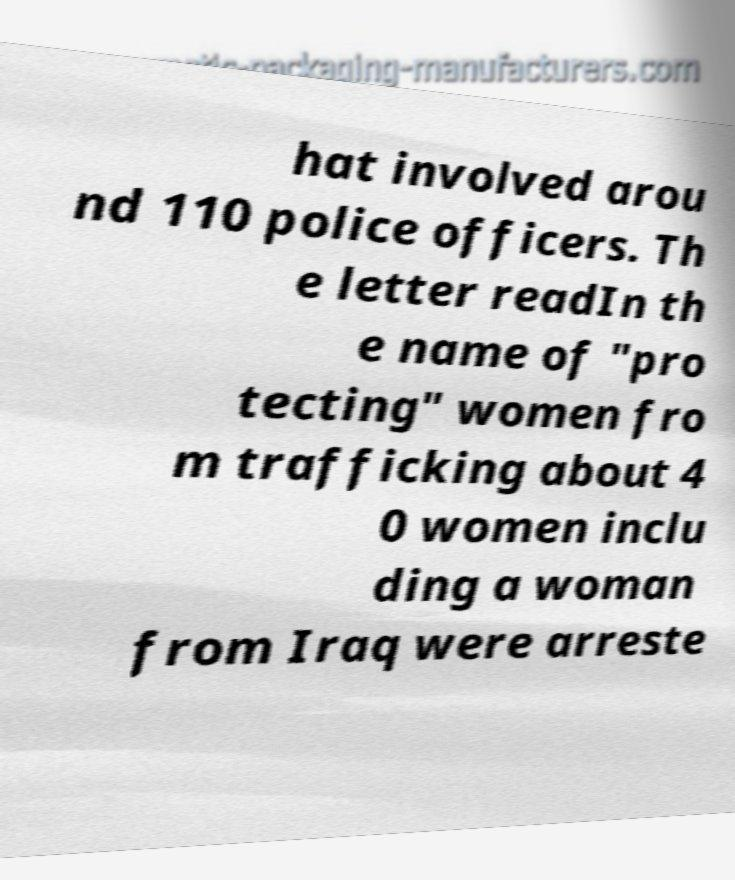There's text embedded in this image that I need extracted. Can you transcribe it verbatim? hat involved arou nd 110 police officers. Th e letter readIn th e name of "pro tecting" women fro m trafficking about 4 0 women inclu ding a woman from Iraq were arreste 